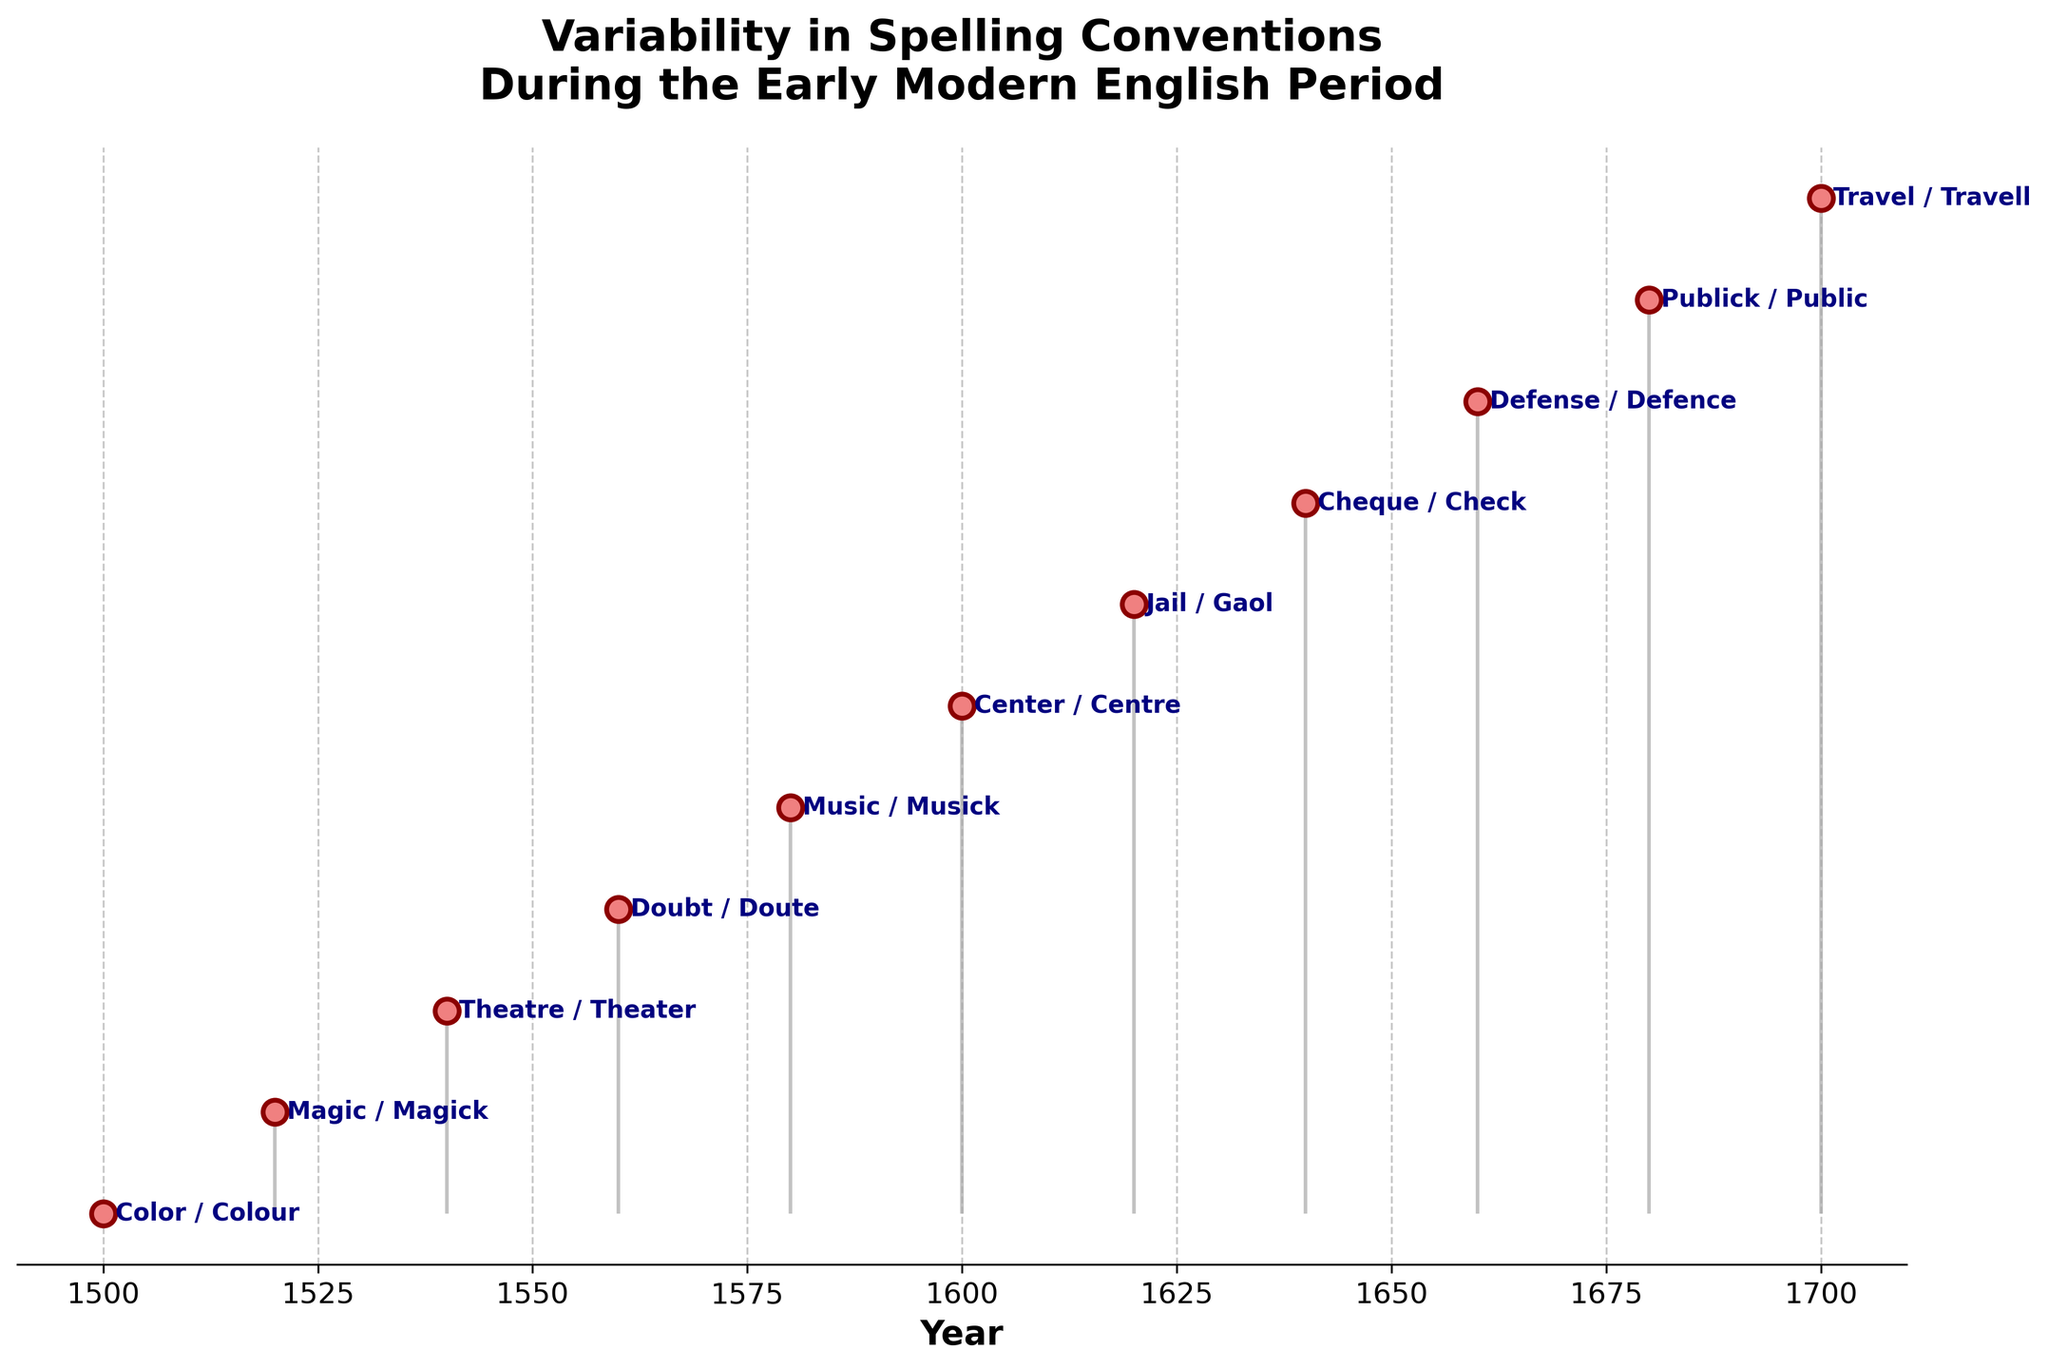What is the title of the figure? The title of the figure is written at the top of the diagram. It states "Variability in Spelling Conventions During the Early Modern English Period".
Answer: Variability in Spelling Conventions During the Early Modern English Period What are the x-axis labels indicating? The x-axis labels are indicating the years during the Early Modern English Period. This can be understood by looking at the label "Year" on the x-axis and the years listed below it.
Answer: Years How many pairs of words and their spelling variants are displayed in the figure? To find the number of pairs, count the number of words listed along the y-axis. There are 11 pairs of words and their spelling variants.
Answer: 11 Which word and its variant appear in the year 1540? Locate the year 1540 on the x-axis and trace it to the corresponding data point. The word and its variant for this year are "Theatre" and "Theater".
Answer: Theatre and Theater Which word and its variant are at the beginning (earliest year) of the timeline? The earliest year is 1500. By following the x-axis to 1500, we see that the word and its variant are "Color" and "Colour".
Answer: Color and Colour Which word and its variant are at the end (latest year) of the timeline? The latest year is 1700. By following the x-axis to 1700, we see that the word and its variant are "Travel" and "Travell".
Answer: Travel and Travell How many total years are covered in the figure? The years range from 1500 to 1700. To find the total number of years covered, subtract the starting year from the ending year: 1700 - 1500 = 200.
Answer: 200 Which spelling variants involve the letter 'k' in one of their forms? Identify pairs where one form contains the letter 'k'. These pairs are "Magic/Magick", "Music/Musick", and "Publick/Public".
Answer: Magic/Magick, Music/Musick, Publick/Public In which decade do "Jail" and "Gaol" appear? To find the decade, locate the year for the pair "Jail" and "Gaol", which is 1620. This falls in the 1620s decade.
Answer: 1620s Which word changes from British to American spelling conventions between 1660 and 1680? Identify the pairs between the years 1660 and 1680. "Defense/Defence" changes spelling variants between these years following British to American conventions.
Answer: Defense/Defence 